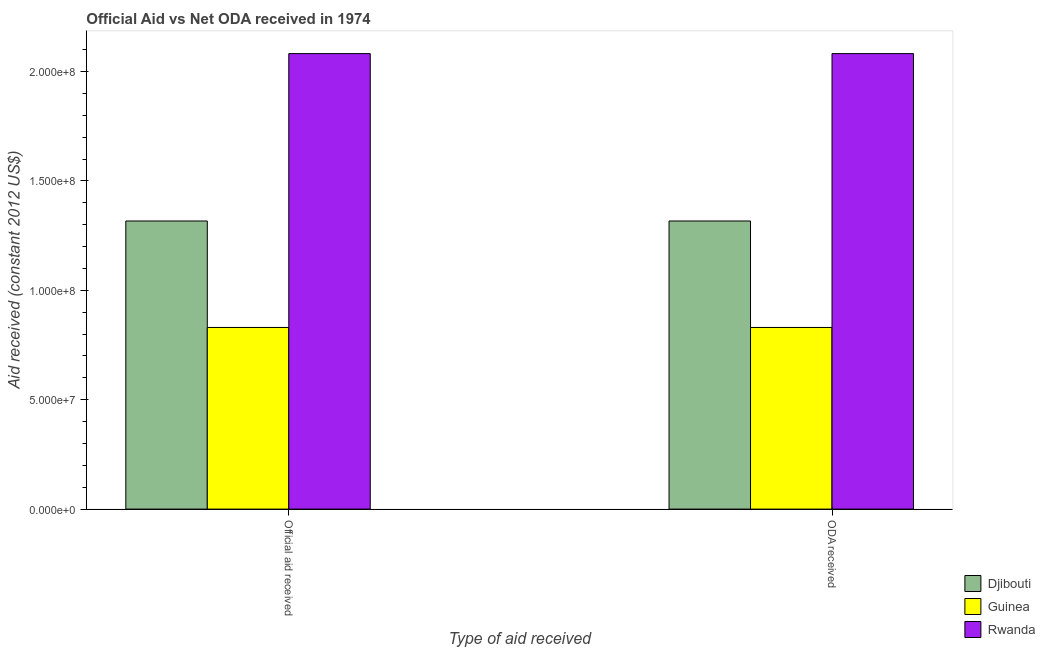Are the number of bars per tick equal to the number of legend labels?
Ensure brevity in your answer.  Yes. Are the number of bars on each tick of the X-axis equal?
Ensure brevity in your answer.  Yes. What is the label of the 1st group of bars from the left?
Keep it short and to the point. Official aid received. What is the official aid received in Rwanda?
Your response must be concise. 2.08e+08. Across all countries, what is the maximum official aid received?
Provide a short and direct response. 2.08e+08. Across all countries, what is the minimum oda received?
Offer a terse response. 8.30e+07. In which country was the official aid received maximum?
Your answer should be compact. Rwanda. In which country was the official aid received minimum?
Your answer should be compact. Guinea. What is the total official aid received in the graph?
Your answer should be compact. 4.23e+08. What is the difference between the oda received in Rwanda and that in Guinea?
Offer a very short reply. 1.25e+08. What is the difference between the official aid received in Rwanda and the oda received in Guinea?
Offer a terse response. 1.25e+08. What is the average oda received per country?
Make the answer very short. 1.41e+08. What is the difference between the official aid received and oda received in Guinea?
Offer a very short reply. 0. In how many countries, is the oda received greater than 200000000 US$?
Your answer should be compact. 1. What is the ratio of the oda received in Rwanda to that in Djibouti?
Offer a very short reply. 1.58. Is the official aid received in Rwanda less than that in Djibouti?
Make the answer very short. No. What does the 2nd bar from the left in ODA received represents?
Your response must be concise. Guinea. What does the 2nd bar from the right in ODA received represents?
Your answer should be compact. Guinea. Are all the bars in the graph horizontal?
Make the answer very short. No. How many countries are there in the graph?
Your answer should be very brief. 3. What is the difference between two consecutive major ticks on the Y-axis?
Offer a terse response. 5.00e+07. Does the graph contain grids?
Provide a short and direct response. No. Where does the legend appear in the graph?
Your response must be concise. Bottom right. How many legend labels are there?
Ensure brevity in your answer.  3. How are the legend labels stacked?
Make the answer very short. Vertical. What is the title of the graph?
Provide a succinct answer. Official Aid vs Net ODA received in 1974 . Does "Serbia" appear as one of the legend labels in the graph?
Offer a very short reply. No. What is the label or title of the X-axis?
Make the answer very short. Type of aid received. What is the label or title of the Y-axis?
Offer a terse response. Aid received (constant 2012 US$). What is the Aid received (constant 2012 US$) in Djibouti in Official aid received?
Ensure brevity in your answer.  1.32e+08. What is the Aid received (constant 2012 US$) in Guinea in Official aid received?
Offer a terse response. 8.30e+07. What is the Aid received (constant 2012 US$) of Rwanda in Official aid received?
Your response must be concise. 2.08e+08. What is the Aid received (constant 2012 US$) in Djibouti in ODA received?
Make the answer very short. 1.32e+08. What is the Aid received (constant 2012 US$) of Guinea in ODA received?
Provide a succinct answer. 8.30e+07. What is the Aid received (constant 2012 US$) in Rwanda in ODA received?
Offer a terse response. 2.08e+08. Across all Type of aid received, what is the maximum Aid received (constant 2012 US$) of Djibouti?
Offer a very short reply. 1.32e+08. Across all Type of aid received, what is the maximum Aid received (constant 2012 US$) of Guinea?
Provide a short and direct response. 8.30e+07. Across all Type of aid received, what is the maximum Aid received (constant 2012 US$) of Rwanda?
Keep it short and to the point. 2.08e+08. Across all Type of aid received, what is the minimum Aid received (constant 2012 US$) of Djibouti?
Provide a succinct answer. 1.32e+08. Across all Type of aid received, what is the minimum Aid received (constant 2012 US$) of Guinea?
Provide a succinct answer. 8.30e+07. Across all Type of aid received, what is the minimum Aid received (constant 2012 US$) of Rwanda?
Keep it short and to the point. 2.08e+08. What is the total Aid received (constant 2012 US$) of Djibouti in the graph?
Offer a terse response. 2.63e+08. What is the total Aid received (constant 2012 US$) of Guinea in the graph?
Offer a very short reply. 1.66e+08. What is the total Aid received (constant 2012 US$) in Rwanda in the graph?
Your answer should be compact. 4.16e+08. What is the difference between the Aid received (constant 2012 US$) of Djibouti in Official aid received and the Aid received (constant 2012 US$) of Guinea in ODA received?
Keep it short and to the point. 4.87e+07. What is the difference between the Aid received (constant 2012 US$) of Djibouti in Official aid received and the Aid received (constant 2012 US$) of Rwanda in ODA received?
Your answer should be very brief. -7.65e+07. What is the difference between the Aid received (constant 2012 US$) of Guinea in Official aid received and the Aid received (constant 2012 US$) of Rwanda in ODA received?
Your answer should be very brief. -1.25e+08. What is the average Aid received (constant 2012 US$) of Djibouti per Type of aid received?
Your answer should be compact. 1.32e+08. What is the average Aid received (constant 2012 US$) of Guinea per Type of aid received?
Provide a succinct answer. 8.30e+07. What is the average Aid received (constant 2012 US$) in Rwanda per Type of aid received?
Offer a very short reply. 2.08e+08. What is the difference between the Aid received (constant 2012 US$) in Djibouti and Aid received (constant 2012 US$) in Guinea in Official aid received?
Provide a succinct answer. 4.87e+07. What is the difference between the Aid received (constant 2012 US$) in Djibouti and Aid received (constant 2012 US$) in Rwanda in Official aid received?
Provide a succinct answer. -7.65e+07. What is the difference between the Aid received (constant 2012 US$) of Guinea and Aid received (constant 2012 US$) of Rwanda in Official aid received?
Make the answer very short. -1.25e+08. What is the difference between the Aid received (constant 2012 US$) of Djibouti and Aid received (constant 2012 US$) of Guinea in ODA received?
Ensure brevity in your answer.  4.87e+07. What is the difference between the Aid received (constant 2012 US$) in Djibouti and Aid received (constant 2012 US$) in Rwanda in ODA received?
Your answer should be compact. -7.65e+07. What is the difference between the Aid received (constant 2012 US$) of Guinea and Aid received (constant 2012 US$) of Rwanda in ODA received?
Your answer should be very brief. -1.25e+08. What is the ratio of the Aid received (constant 2012 US$) of Djibouti in Official aid received to that in ODA received?
Provide a short and direct response. 1. What is the ratio of the Aid received (constant 2012 US$) of Guinea in Official aid received to that in ODA received?
Make the answer very short. 1. What is the ratio of the Aid received (constant 2012 US$) in Rwanda in Official aid received to that in ODA received?
Give a very brief answer. 1. What is the difference between the highest and the second highest Aid received (constant 2012 US$) in Djibouti?
Give a very brief answer. 0. What is the difference between the highest and the lowest Aid received (constant 2012 US$) of Guinea?
Provide a short and direct response. 0. 